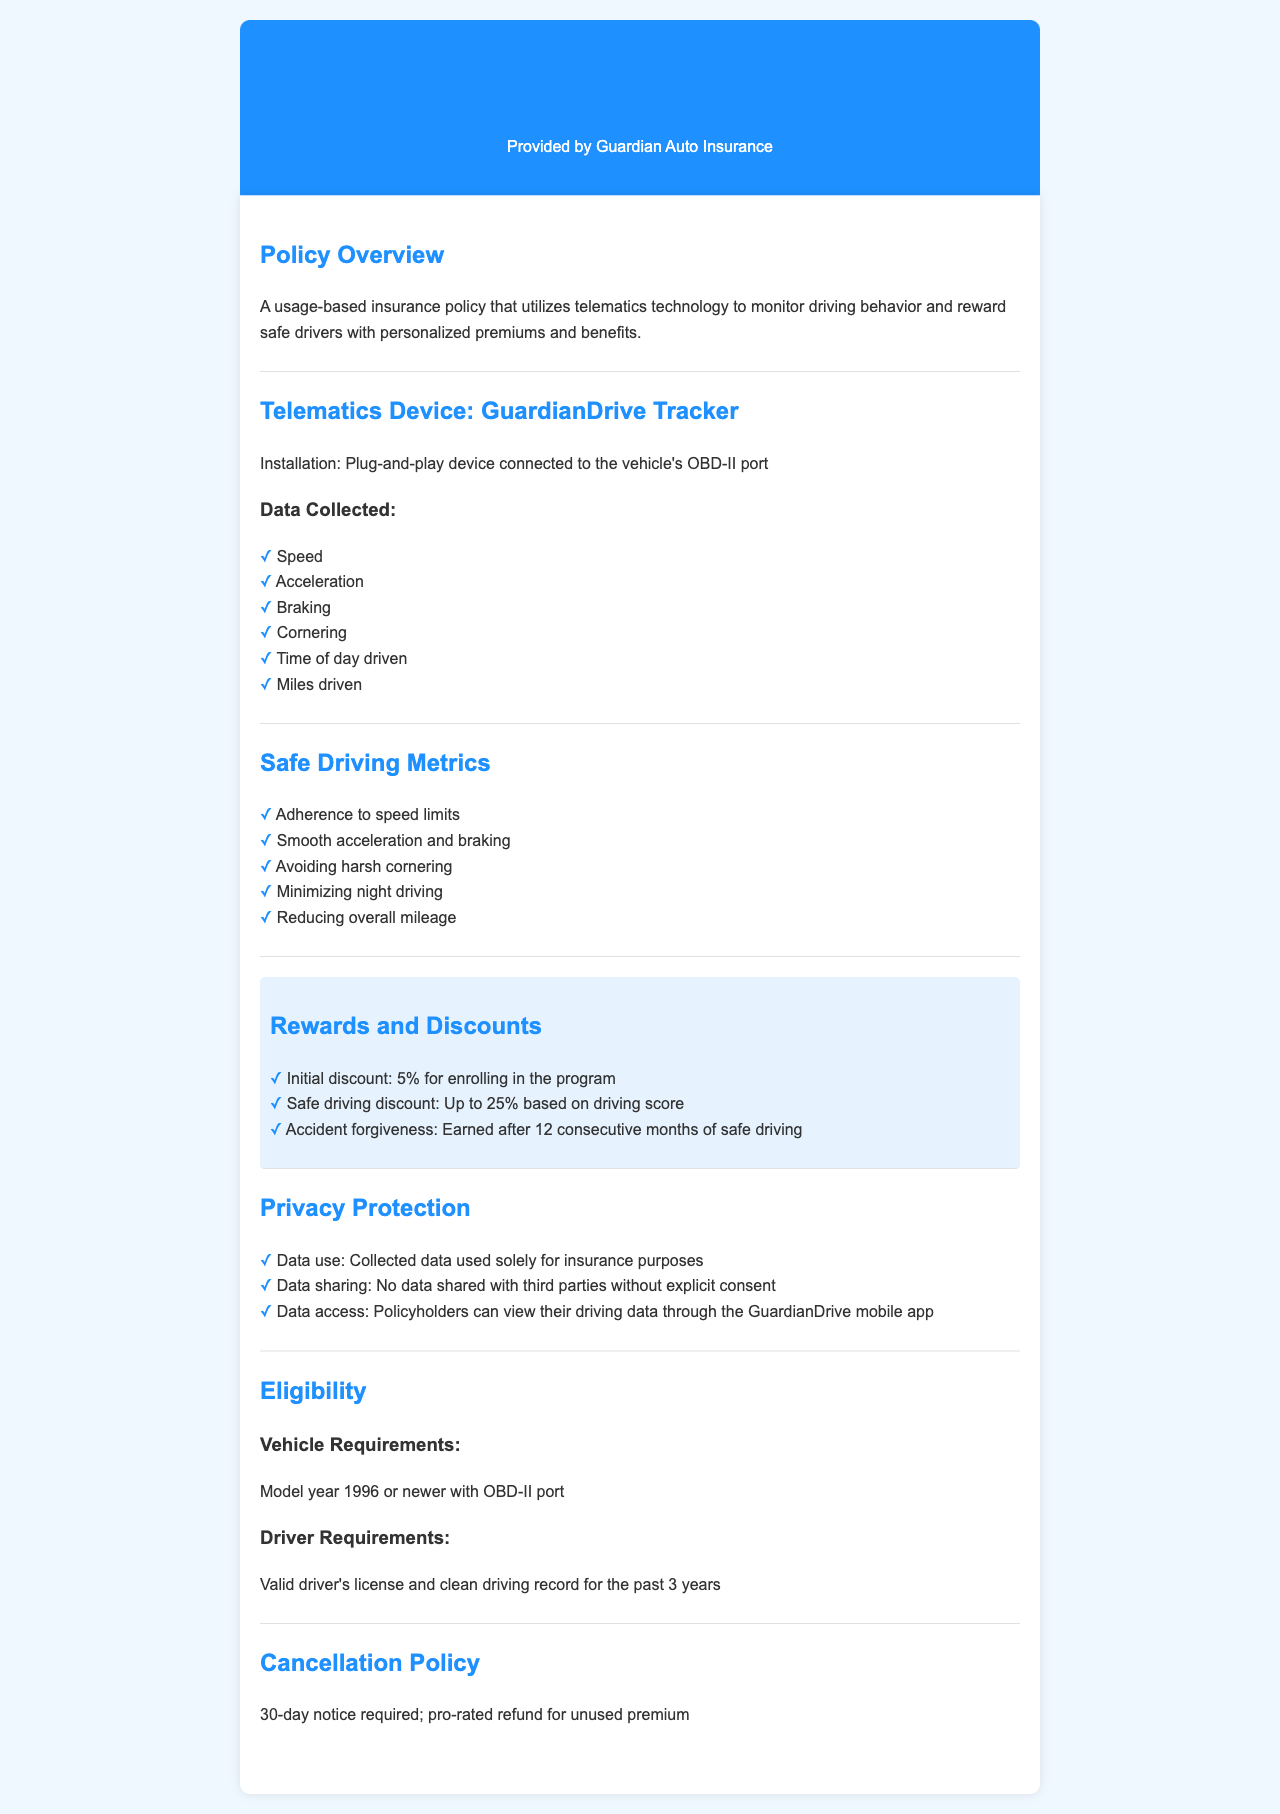What is the name of the telematics device? The document mentions the telematics device as the GuardianDrive Tracker.
Answer: GuardianDrive Tracker What discount is provided for enrolling in the program? The policy states the initial discount for enrolling is 5%.
Answer: 5% What data is collected regarding driving behavior? The document lists several data points including speed, acceleration, braking, cornering, time of day driven, and miles driven.
Answer: Speed, acceleration, braking, cornering, time of day driven, miles driven How much can a safe driving discount be? According to the policy, the safe driving discount can be up to 25% based on driving score.
Answer: Up to 25% What is the notice period required for cancellation? The document states that a 30-day notice is required for cancellation of the policy.
Answer: 30-day What are the vehicle requirements for eligibility? The eligibility criteria specify that vehicles must be model year 1996 or newer with an OBD-II port.
Answer: Model year 1996 or newer with OBD-II port What is the accident forgiveness period? The policy states that accident forgiveness is earned after 12 consecutive months of safe driving.
Answer: 12 consecutive months What is the primary use of the collected data? The document explicitly states that the collected data is used solely for insurance purposes.
Answer: Insurance purposes 